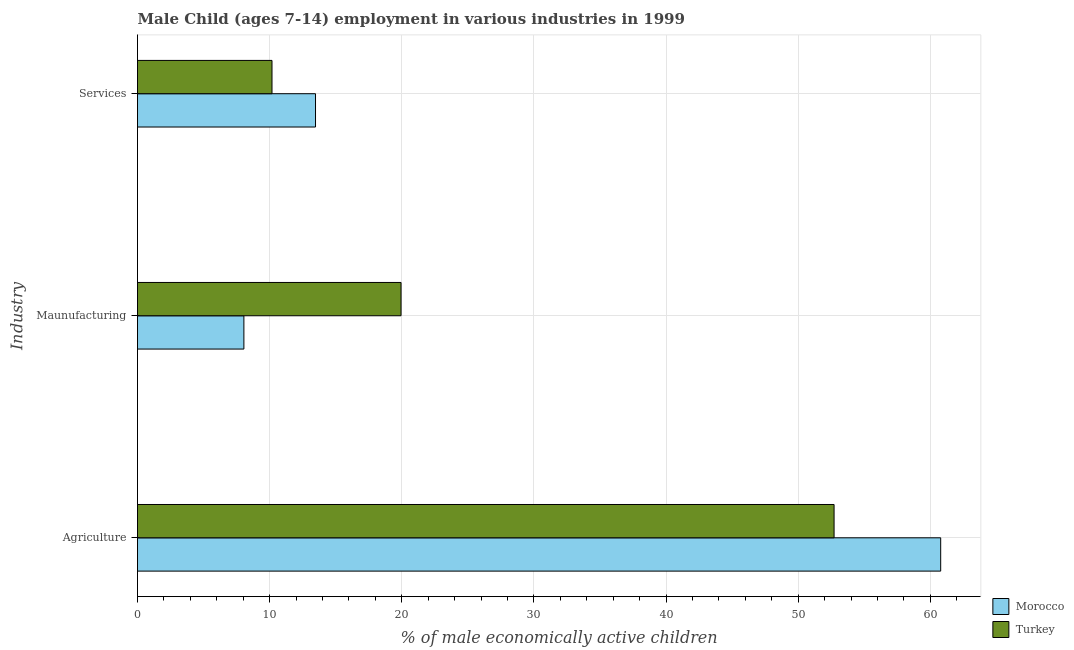How many bars are there on the 2nd tick from the bottom?
Provide a succinct answer. 2. What is the label of the 1st group of bars from the top?
Make the answer very short. Services. What is the percentage of economically active children in services in Turkey?
Your response must be concise. 10.18. Across all countries, what is the maximum percentage of economically active children in services?
Keep it short and to the point. 13.47. Across all countries, what is the minimum percentage of economically active children in manufacturing?
Your answer should be very brief. 8.05. In which country was the percentage of economically active children in services maximum?
Give a very brief answer. Morocco. What is the total percentage of economically active children in manufacturing in the graph?
Ensure brevity in your answer.  27.99. What is the difference between the percentage of economically active children in manufacturing in Turkey and that in Morocco?
Provide a short and direct response. 11.89. What is the difference between the percentage of economically active children in manufacturing in Turkey and the percentage of economically active children in services in Morocco?
Make the answer very short. 6.47. What is the average percentage of economically active children in agriculture per country?
Your response must be concise. 56.75. What is the difference between the percentage of economically active children in agriculture and percentage of economically active children in services in Morocco?
Your answer should be compact. 47.31. In how many countries, is the percentage of economically active children in agriculture greater than 32 %?
Offer a terse response. 2. What is the ratio of the percentage of economically active children in agriculture in Turkey to that in Morocco?
Your answer should be very brief. 0.87. Is the percentage of economically active children in agriculture in Morocco less than that in Turkey?
Keep it short and to the point. No. What is the difference between the highest and the second highest percentage of economically active children in agriculture?
Your answer should be very brief. 8.07. What is the difference between the highest and the lowest percentage of economically active children in agriculture?
Provide a short and direct response. 8.07. Is the sum of the percentage of economically active children in services in Turkey and Morocco greater than the maximum percentage of economically active children in manufacturing across all countries?
Offer a very short reply. Yes. What does the 1st bar from the bottom in Services represents?
Offer a terse response. Morocco. Are all the bars in the graph horizontal?
Your answer should be very brief. Yes. What is the difference between two consecutive major ticks on the X-axis?
Your answer should be compact. 10. Does the graph contain grids?
Make the answer very short. Yes. Where does the legend appear in the graph?
Ensure brevity in your answer.  Bottom right. How many legend labels are there?
Your response must be concise. 2. How are the legend labels stacked?
Offer a very short reply. Vertical. What is the title of the graph?
Offer a terse response. Male Child (ages 7-14) employment in various industries in 1999. What is the label or title of the X-axis?
Your answer should be compact. % of male economically active children. What is the label or title of the Y-axis?
Make the answer very short. Industry. What is the % of male economically active children in Morocco in Agriculture?
Keep it short and to the point. 60.78. What is the % of male economically active children in Turkey in Agriculture?
Provide a succinct answer. 52.71. What is the % of male economically active children in Morocco in Maunufacturing?
Offer a terse response. 8.05. What is the % of male economically active children of Turkey in Maunufacturing?
Ensure brevity in your answer.  19.94. What is the % of male economically active children of Morocco in Services?
Provide a succinct answer. 13.47. What is the % of male economically active children in Turkey in Services?
Give a very brief answer. 10.18. Across all Industry, what is the maximum % of male economically active children in Morocco?
Your answer should be very brief. 60.78. Across all Industry, what is the maximum % of male economically active children of Turkey?
Offer a very short reply. 52.71. Across all Industry, what is the minimum % of male economically active children of Morocco?
Your answer should be compact. 8.05. Across all Industry, what is the minimum % of male economically active children in Turkey?
Provide a short and direct response. 10.18. What is the total % of male economically active children in Morocco in the graph?
Provide a short and direct response. 82.3. What is the total % of male economically active children in Turkey in the graph?
Your answer should be compact. 82.83. What is the difference between the % of male economically active children in Morocco in Agriculture and that in Maunufacturing?
Provide a short and direct response. 52.73. What is the difference between the % of male economically active children of Turkey in Agriculture and that in Maunufacturing?
Keep it short and to the point. 32.77. What is the difference between the % of male economically active children of Morocco in Agriculture and that in Services?
Your response must be concise. 47.31. What is the difference between the % of male economically active children of Turkey in Agriculture and that in Services?
Provide a succinct answer. 42.53. What is the difference between the % of male economically active children in Morocco in Maunufacturing and that in Services?
Keep it short and to the point. -5.42. What is the difference between the % of male economically active children in Turkey in Maunufacturing and that in Services?
Ensure brevity in your answer.  9.77. What is the difference between the % of male economically active children of Morocco in Agriculture and the % of male economically active children of Turkey in Maunufacturing?
Provide a short and direct response. 40.84. What is the difference between the % of male economically active children in Morocco in Agriculture and the % of male economically active children in Turkey in Services?
Offer a terse response. 50.6. What is the difference between the % of male economically active children of Morocco in Maunufacturing and the % of male economically active children of Turkey in Services?
Provide a succinct answer. -2.13. What is the average % of male economically active children of Morocco per Industry?
Your response must be concise. 27.43. What is the average % of male economically active children in Turkey per Industry?
Ensure brevity in your answer.  27.61. What is the difference between the % of male economically active children of Morocco and % of male economically active children of Turkey in Agriculture?
Provide a succinct answer. 8.07. What is the difference between the % of male economically active children of Morocco and % of male economically active children of Turkey in Maunufacturing?
Make the answer very short. -11.89. What is the difference between the % of male economically active children of Morocco and % of male economically active children of Turkey in Services?
Offer a terse response. 3.29. What is the ratio of the % of male economically active children in Morocco in Agriculture to that in Maunufacturing?
Offer a very short reply. 7.55. What is the ratio of the % of male economically active children of Turkey in Agriculture to that in Maunufacturing?
Provide a succinct answer. 2.64. What is the ratio of the % of male economically active children of Morocco in Agriculture to that in Services?
Your answer should be very brief. 4.51. What is the ratio of the % of male economically active children of Turkey in Agriculture to that in Services?
Ensure brevity in your answer.  5.18. What is the ratio of the % of male economically active children in Morocco in Maunufacturing to that in Services?
Make the answer very short. 0.6. What is the ratio of the % of male economically active children in Turkey in Maunufacturing to that in Services?
Your answer should be very brief. 1.96. What is the difference between the highest and the second highest % of male economically active children in Morocco?
Keep it short and to the point. 47.31. What is the difference between the highest and the second highest % of male economically active children of Turkey?
Provide a short and direct response. 32.77. What is the difference between the highest and the lowest % of male economically active children in Morocco?
Your answer should be very brief. 52.73. What is the difference between the highest and the lowest % of male economically active children in Turkey?
Offer a terse response. 42.53. 